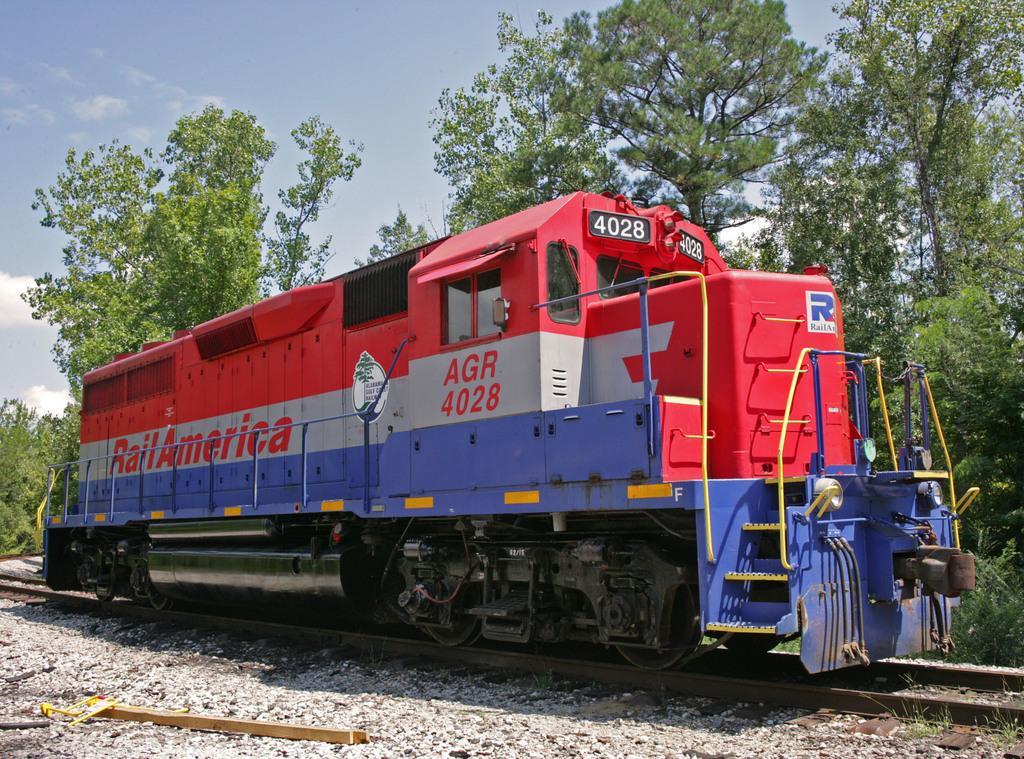How would you summarize this image in a sentence or two? In the image there is a train moving on rail track and behind it there are trees all over place and above its sky. 